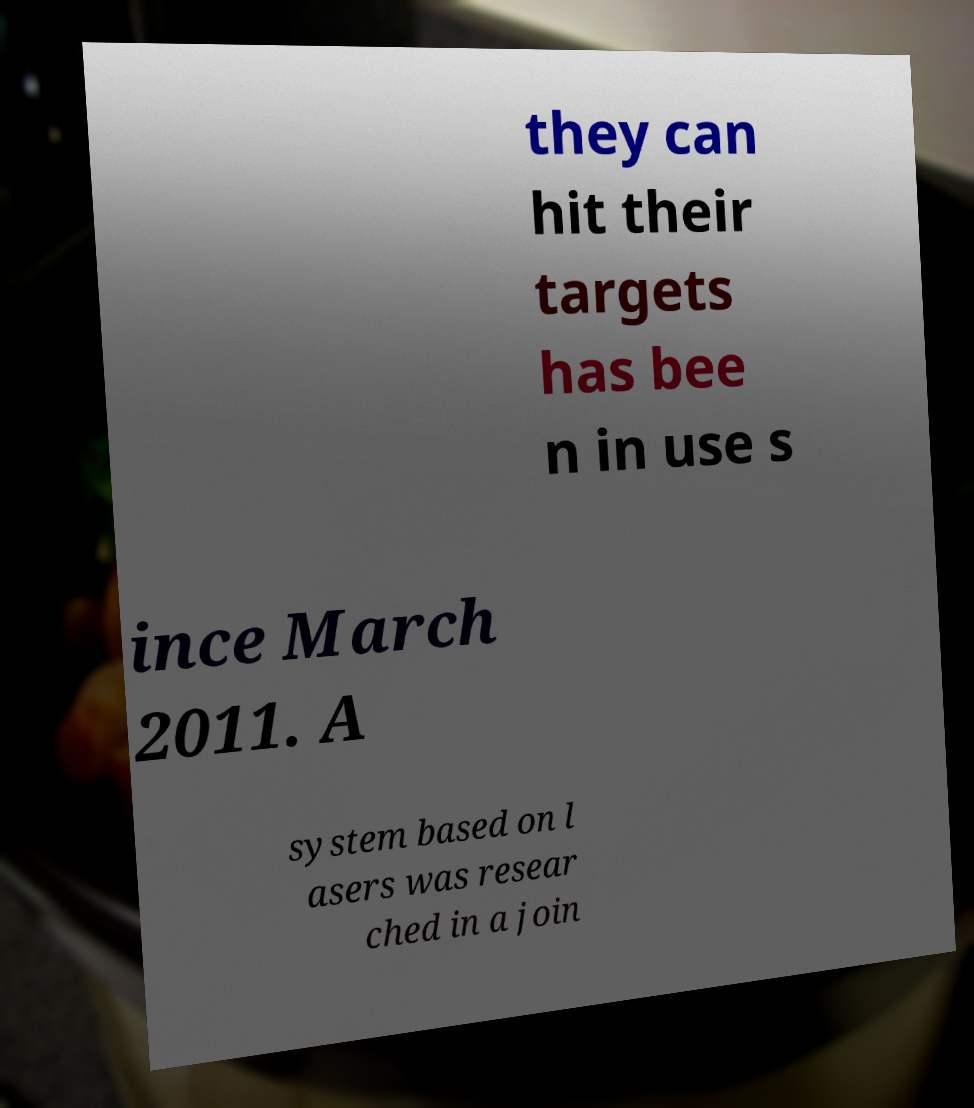Could you extract and type out the text from this image? they can hit their targets has bee n in use s ince March 2011. A system based on l asers was resear ched in a join 